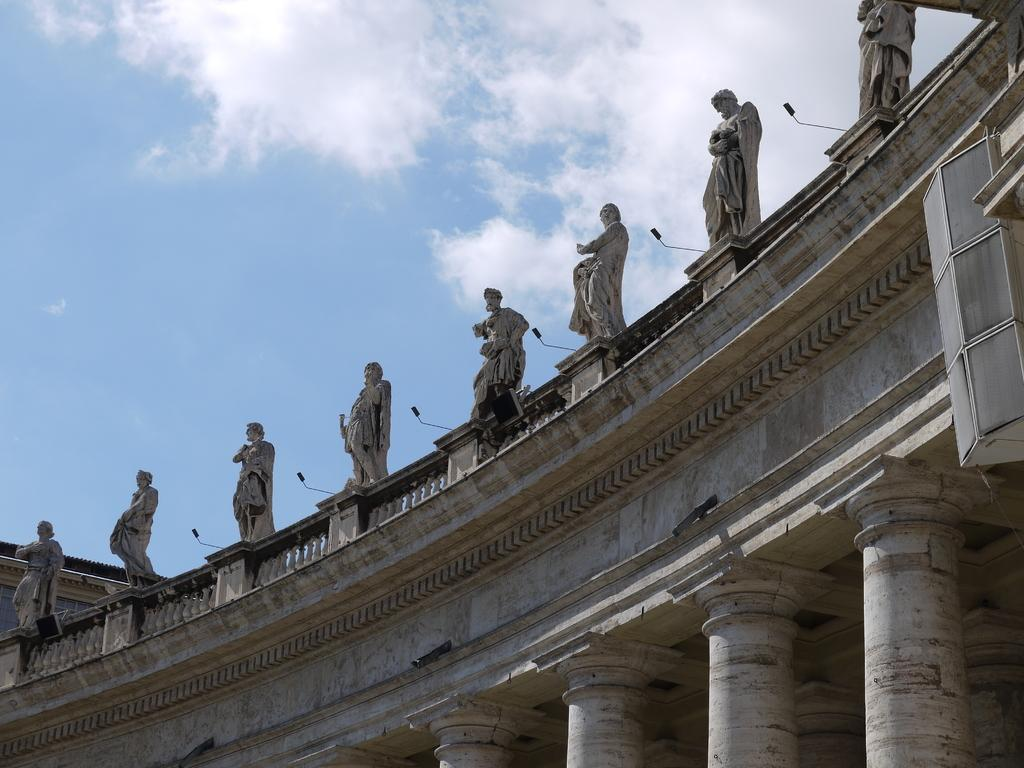What can be seen on the building in the image? There are statues of persons on the building. What type of barrier surrounds the building? The building has a fence. What architectural feature is present on the building? The building has pillars. What is visible in the sky in the image? There are clouds in the sky. What color is the sky in the image? The sky is blue in the image. Where is the cherry placed on the table in the image? There is no cherry or table present in the image. What type of monkey can be seen climbing the pillars in the image? There are no monkeys present in the image; only statues of persons and architectural features are visible. 